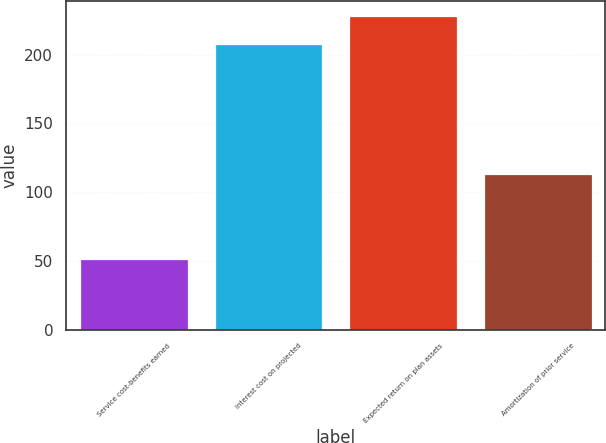Convert chart. <chart><loc_0><loc_0><loc_500><loc_500><bar_chart><fcel>Service cost-benefits earned<fcel>Interest cost on projected<fcel>Expected return on plan assets<fcel>Amortization of prior service<nl><fcel>51<fcel>208<fcel>228<fcel>113<nl></chart> 